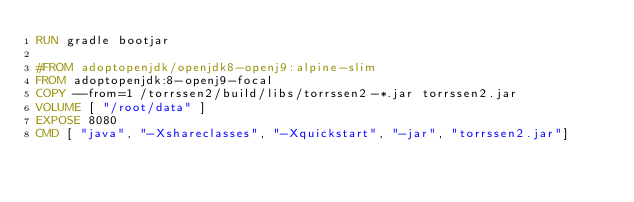<code> <loc_0><loc_0><loc_500><loc_500><_Dockerfile_>RUN gradle bootjar

#FROM adoptopenjdk/openjdk8-openj9:alpine-slim
FROM adoptopenjdk:8-openj9-focal
COPY --from=1 /torrssen2/build/libs/torrssen2-*.jar torrssen2.jar
VOLUME [ "/root/data" ]
EXPOSE 8080
CMD [ "java", "-Xshareclasses", "-Xquickstart", "-jar", "torrssen2.jar"]
</code> 